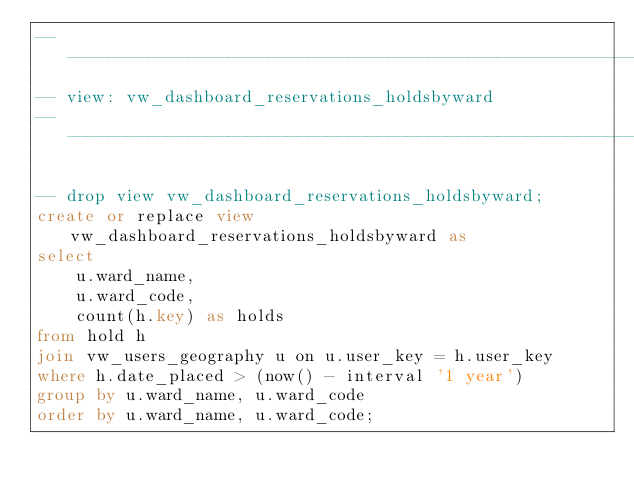<code> <loc_0><loc_0><loc_500><loc_500><_SQL_>---------------------------------------------------------------
-- view: vw_dashboard_reservations_holdsbyward
---------------------------------------------------------------

-- drop view vw_dashboard_reservations_holdsbyward;
create or replace view vw_dashboard_reservations_holdsbyward as 
select 
    u.ward_name,
    u.ward_code,
    count(h.key) as holds
from hold h
join vw_users_geography u on u.user_key = h.user_key
where h.date_placed > (now() - interval '1 year')
group by u.ward_name, u.ward_code
order by u.ward_name, u.ward_code;</code> 